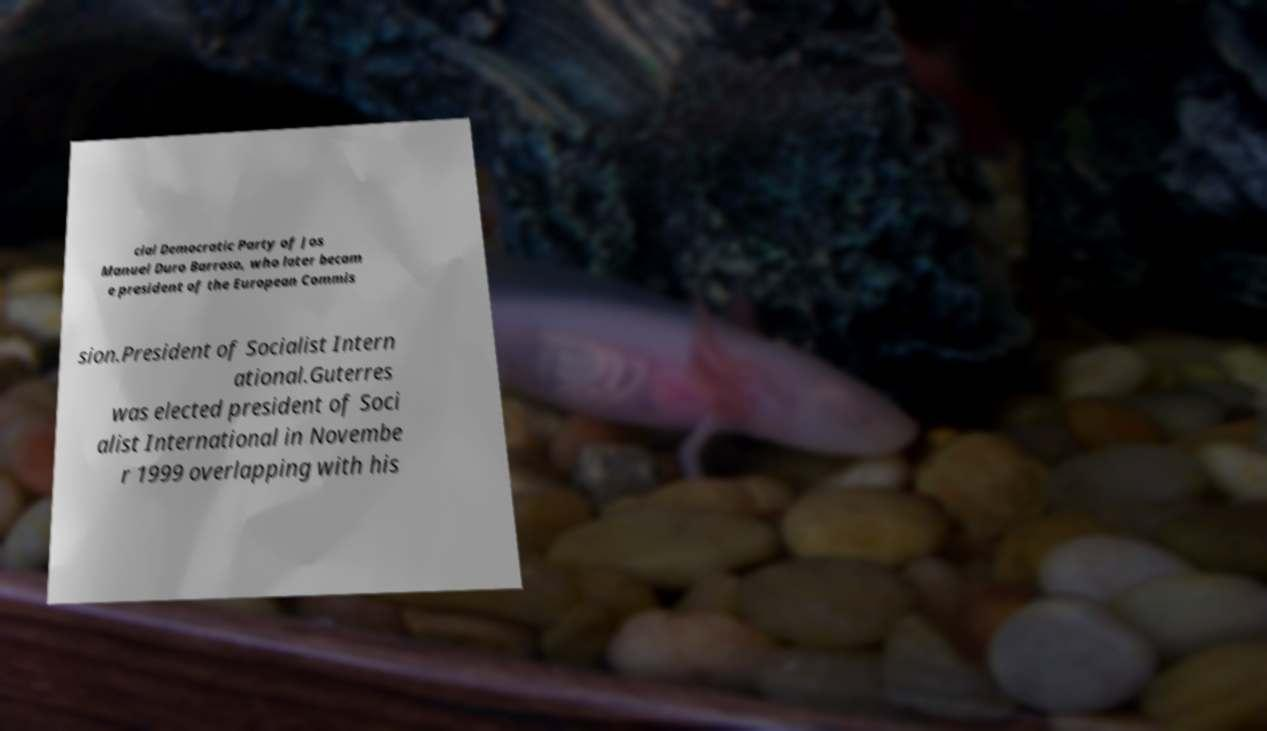Could you extract and type out the text from this image? cial Democratic Party of Jos Manuel Duro Barroso, who later becam e president of the European Commis sion.President of Socialist Intern ational.Guterres was elected president of Soci alist International in Novembe r 1999 overlapping with his 